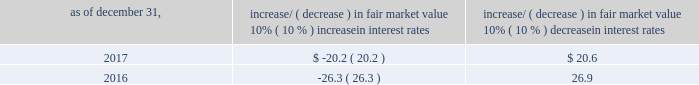Item 7a .
Quantitative and qualitative disclosures about market risk ( amounts in millions ) in the normal course of business , we are exposed to market risks related to interest rates , foreign currency rates and certain balance sheet items .
From time to time , we use derivative instruments , pursuant to established guidelines and policies , to manage some portion of these risks .
Derivative instruments utilized in our hedging activities are viewed as risk management tools and are not used for trading or speculative purposes .
Interest rates our exposure to market risk for changes in interest rates relates primarily to the fair market value and cash flows of our debt obligations .
The majority of our debt ( approximately 94% ( 94 % ) and 93% ( 93 % ) as of december 31 , 2017 and 2016 , respectively ) bears interest at fixed rates .
We do have debt with variable interest rates , but a 10% ( 10 % ) increase or decrease in interest rates would not be material to our interest expense or cash flows .
The fair market value of our debt is sensitive to changes in interest rates , and the impact of a 10% ( 10 % ) change in interest rates is summarized below .
Increase/ ( decrease ) in fair market value as of december 31 , 10% ( 10 % ) increase in interest rates 10% ( 10 % ) decrease in interest rates .
We have used interest rate swaps for risk management purposes to manage our exposure to changes in interest rates .
We did not have any interest rate swaps outstanding as of december 31 , 2017 .
We had $ 791.0 of cash , cash equivalents and marketable securities as of december 31 , 2017 that we generally invest in conservative , short-term bank deposits or securities .
The interest income generated from these investments is subject to both domestic and foreign interest rate movements .
During 2017 and 2016 , we had interest income of $ 19.4 and $ 20.1 , respectively .
Based on our 2017 results , a 100 basis-point increase or decrease in interest rates would affect our interest income by approximately $ 7.9 , assuming that all cash , cash equivalents and marketable securities are impacted in the same manner and balances remain constant from year-end 2017 levels .
Foreign currency rates we are subject to translation and transaction risks related to changes in foreign currency exchange rates .
Since we report revenues and expenses in u.s .
Dollars , changes in exchange rates may either positively or negatively affect our consolidated revenues and expenses ( as expressed in u.s .
Dollars ) from foreign operations .
The foreign currencies that most impacted our results during 2017 included the british pound sterling and , to a lesser extent , brazilian real and south african rand .
Based on 2017 exchange rates and operating results , if the u.s .
Dollar were to strengthen or weaken by 10% ( 10 % ) , we currently estimate operating income would decrease or increase approximately 4% ( 4 % ) , assuming that all currencies are impacted in the same manner and our international revenue and expenses remain constant at 2017 levels .
The functional currency of our foreign operations is generally their respective local currency .
Assets and liabilities are translated at the exchange rates in effect at the balance sheet date , and revenues and expenses are translated at the average exchange rates during the period presented .
The resulting translation adjustments are recorded as a component of accumulated other comprehensive loss , net of tax , in the stockholders 2019 equity section of our consolidated balance sheets .
Our foreign subsidiaries generally collect revenues and pay expenses in their functional currency , mitigating transaction risk .
However , certain subsidiaries may enter into transactions in currencies other than their functional currency .
Assets and liabilities denominated in currencies other than the functional currency are susceptible to movements in foreign currency until final settlement .
Currency transaction gains or losses primarily arising from transactions in currencies other than the functional currency are included in office and general expenses .
We regularly review our foreign exchange exposures that may have a material impact on our business and from time to time use foreign currency forward exchange contracts or other derivative financial instruments to hedge the effects of potential adverse fluctuations in foreign currency exchange rates arising from these exposures .
We do not enter into foreign exchange contracts or other derivatives for speculative purposes. .
What is the mathematical range in 2017 for 10% ( 10 % ) increase and 10% ( 10 % ) decrease in interest rate? 
Computations: (20.2 + 20.6)
Answer: 40.8. 